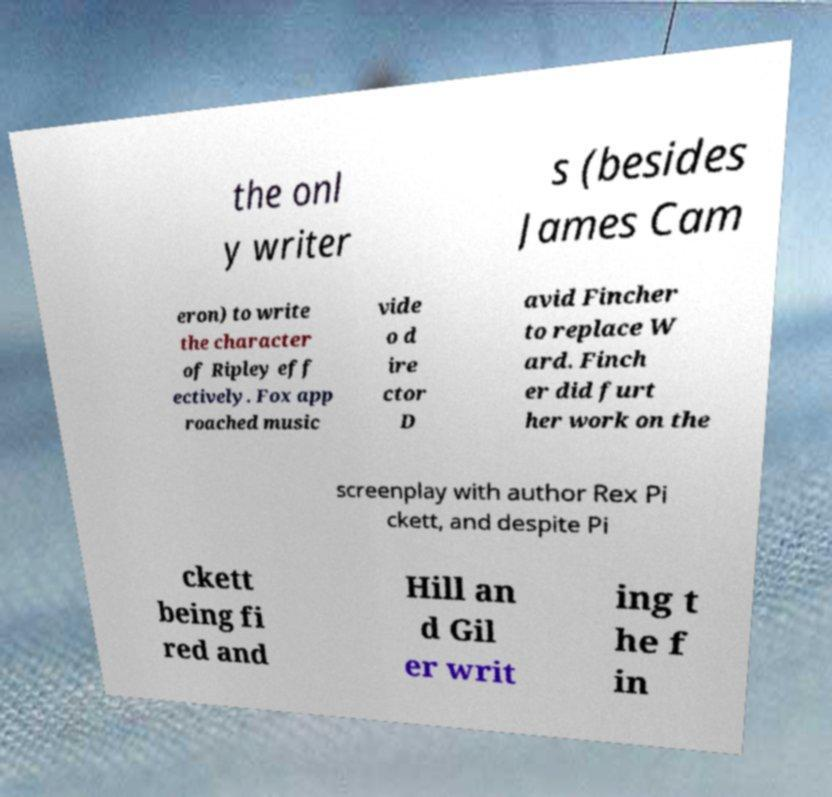What messages or text are displayed in this image? I need them in a readable, typed format. the onl y writer s (besides James Cam eron) to write the character of Ripley eff ectively. Fox app roached music vide o d ire ctor D avid Fincher to replace W ard. Finch er did furt her work on the screenplay with author Rex Pi ckett, and despite Pi ckett being fi red and Hill an d Gil er writ ing t he f in 